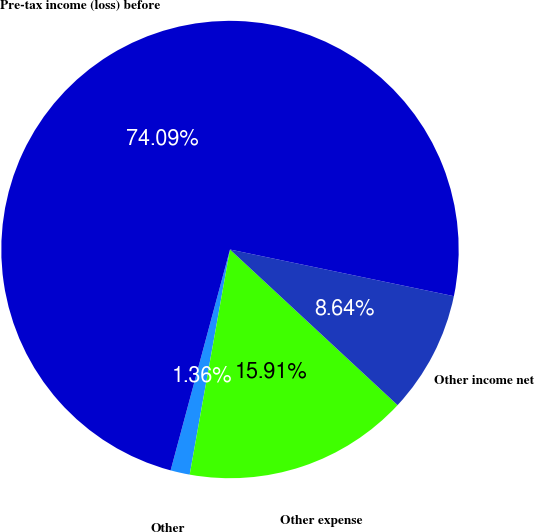Convert chart to OTSL. <chart><loc_0><loc_0><loc_500><loc_500><pie_chart><fcel>Other<fcel>Other expense<fcel>Other income net<fcel>Pre-tax income (loss) before<nl><fcel>1.36%<fcel>15.91%<fcel>8.64%<fcel>74.09%<nl></chart> 